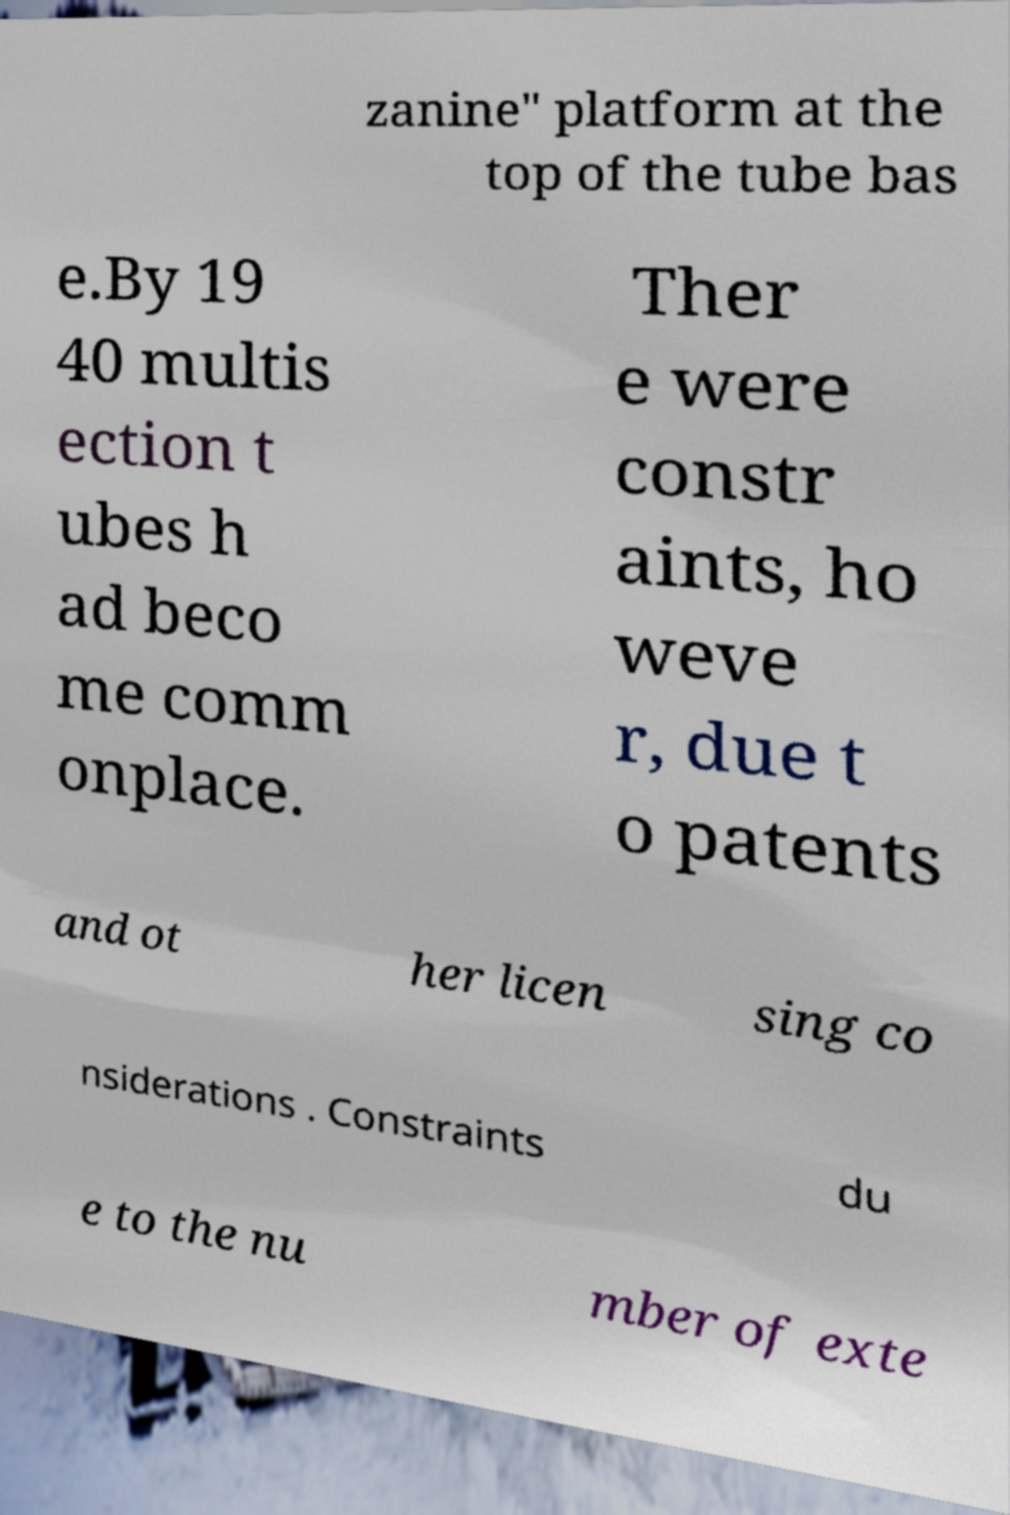What messages or text are displayed in this image? I need them in a readable, typed format. zanine" platform at the top of the tube bas e.By 19 40 multis ection t ubes h ad beco me comm onplace. Ther e were constr aints, ho weve r, due t o patents and ot her licen sing co nsiderations . Constraints du e to the nu mber of exte 